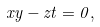<formula> <loc_0><loc_0><loc_500><loc_500>x y - z t = 0 ,</formula> 